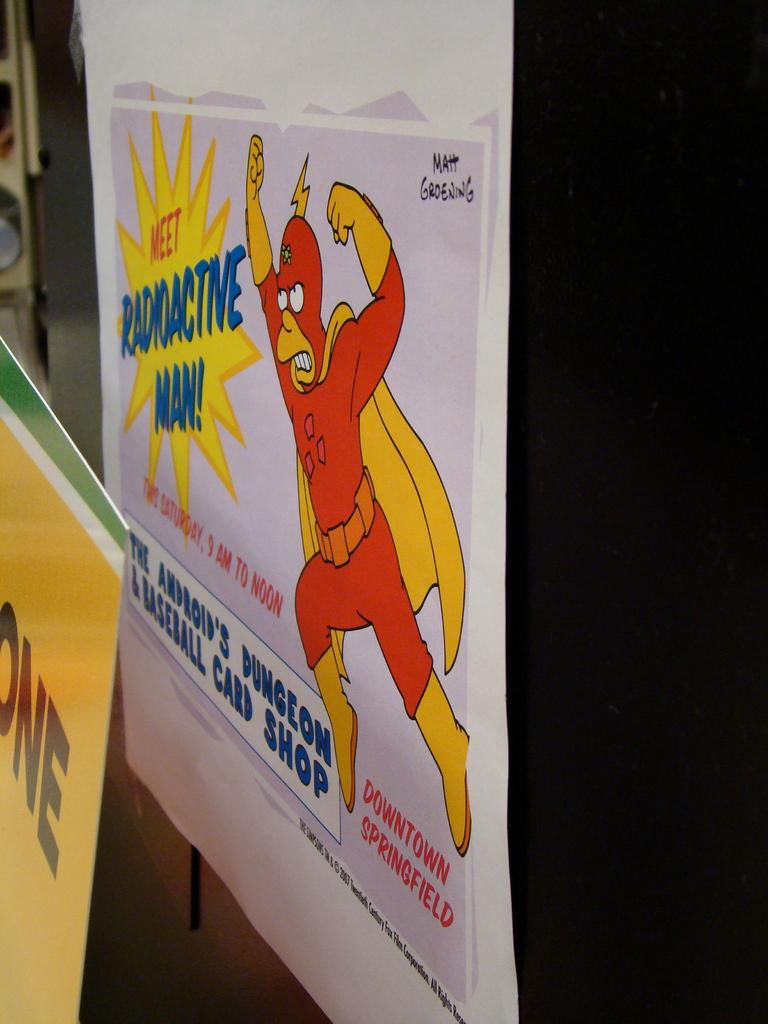Provide a one-sentence caption for the provided image. A poster from the Simpsons that says Meet Radioactive Man. 